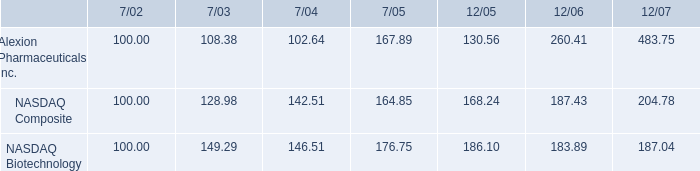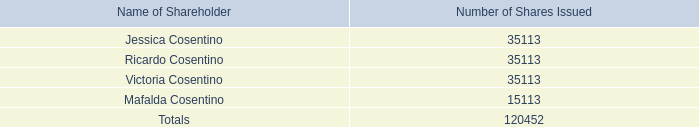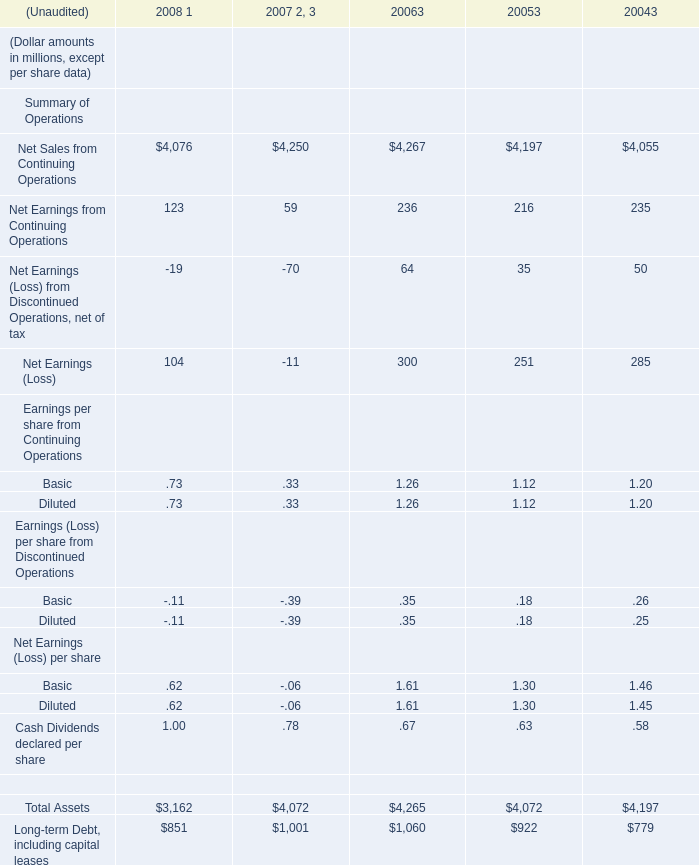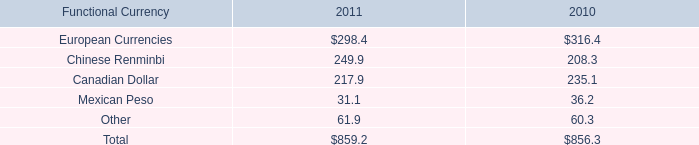What's the sum of Victoria Cosentino of Number of Shares Issued, and Net Sales from Continuing Operations of 2008 1 ? 
Computations: (35113.0 + 4076.0)
Answer: 39189.0. 